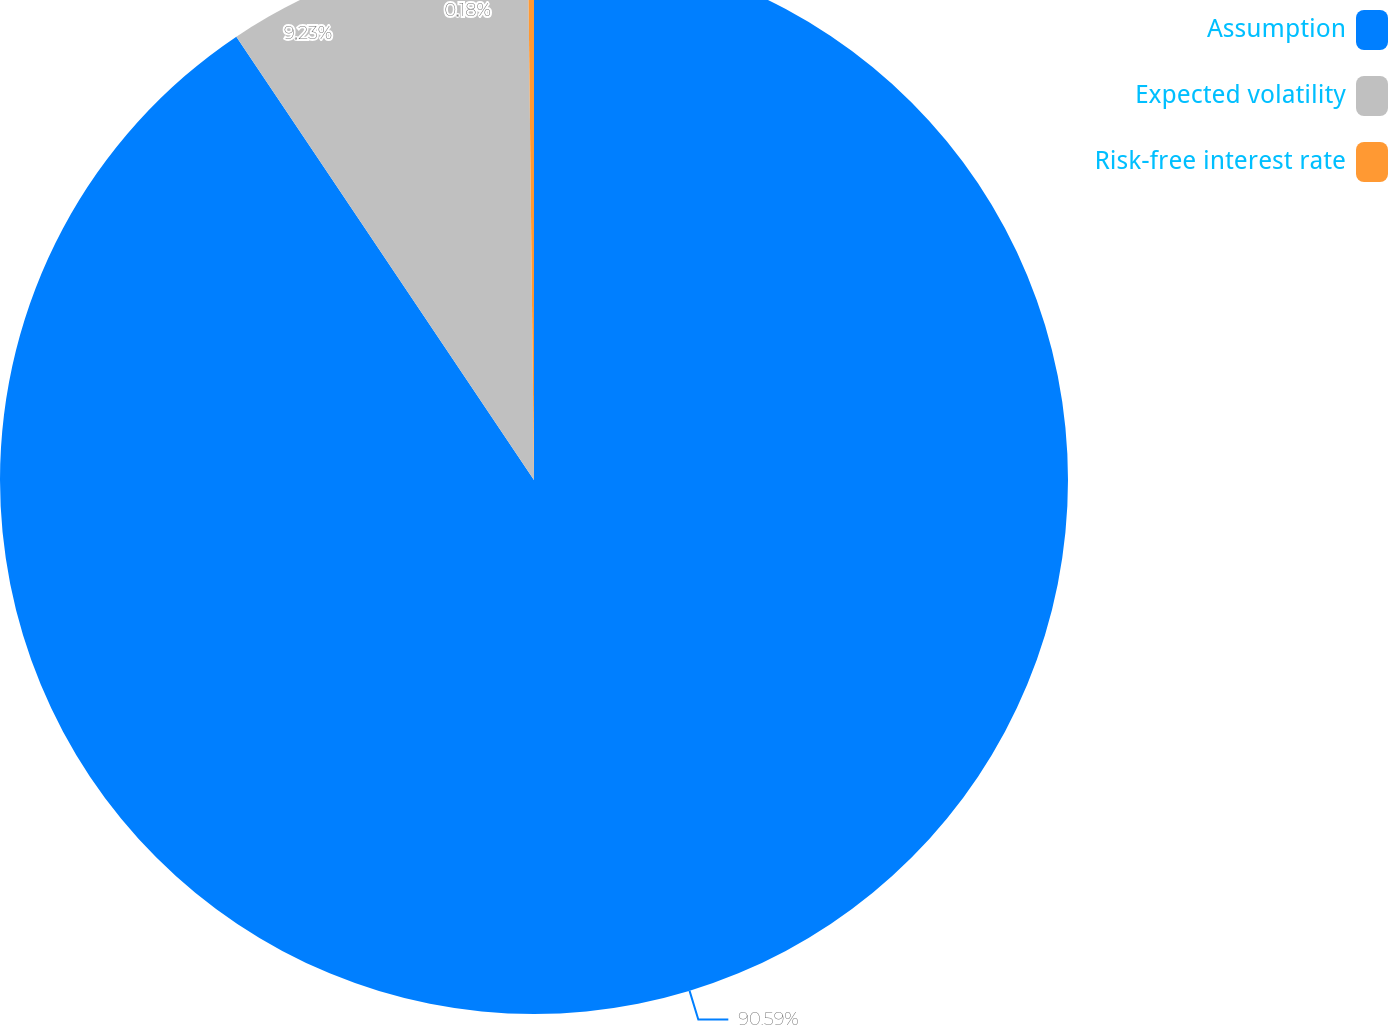<chart> <loc_0><loc_0><loc_500><loc_500><pie_chart><fcel>Assumption<fcel>Expected volatility<fcel>Risk-free interest rate<nl><fcel>90.59%<fcel>9.23%<fcel>0.18%<nl></chart> 